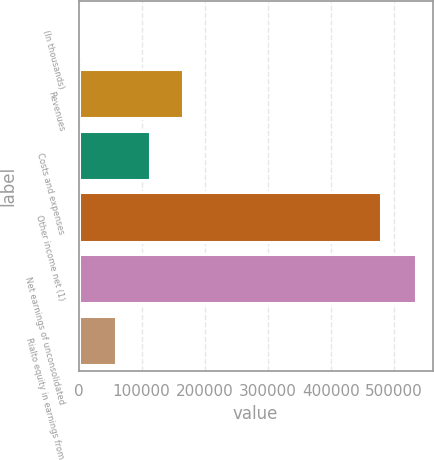<chart> <loc_0><loc_0><loc_500><loc_500><bar_chart><fcel>(In thousands)<fcel>Revenues<fcel>Costs and expenses<fcel>Other income net (1)<fcel>Net earnings of unconsolidated<fcel>Rialto equity in earnings from<nl><fcel>2014<fcel>165825<fcel>112551<fcel>479929<fcel>534752<fcel>59277<nl></chart> 